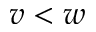Convert formula to latex. <formula><loc_0><loc_0><loc_500><loc_500>v < w</formula> 